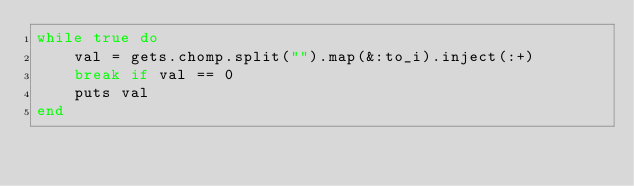Convert code to text. <code><loc_0><loc_0><loc_500><loc_500><_Ruby_>while true do
    val = gets.chomp.split("").map(&:to_i).inject(:+)
    break if val == 0
    puts val
end
</code> 